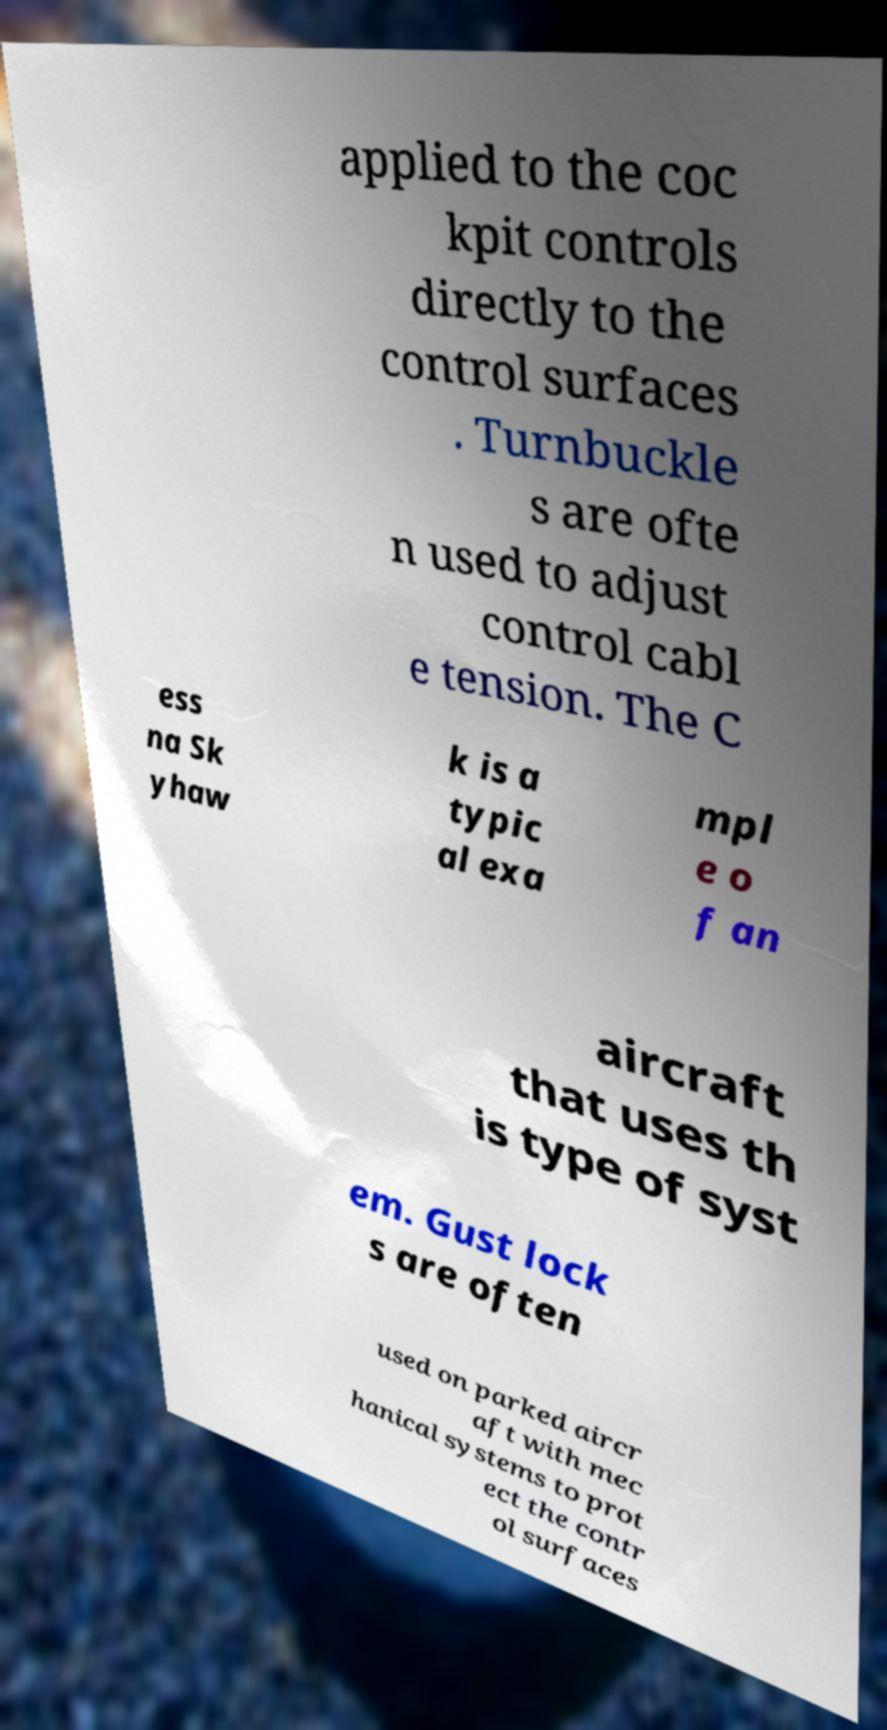There's text embedded in this image that I need extracted. Can you transcribe it verbatim? applied to the coc kpit controls directly to the control surfaces . Turnbuckle s are ofte n used to adjust control cabl e tension. The C ess na Sk yhaw k is a typic al exa mpl e o f an aircraft that uses th is type of syst em. Gust lock s are often used on parked aircr aft with mec hanical systems to prot ect the contr ol surfaces 